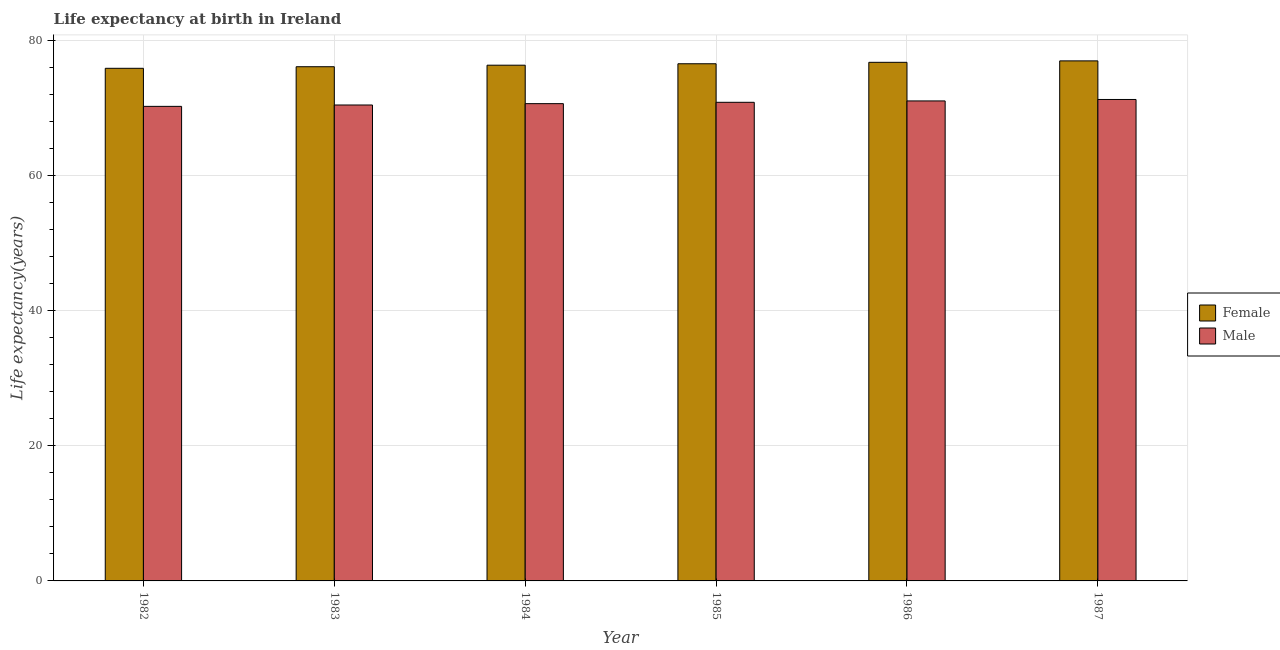Are the number of bars on each tick of the X-axis equal?
Give a very brief answer. Yes. What is the label of the 5th group of bars from the left?
Offer a terse response. 1986. What is the life expectancy(female) in 1986?
Give a very brief answer. 76.78. Across all years, what is the maximum life expectancy(female)?
Ensure brevity in your answer.  76.99. Across all years, what is the minimum life expectancy(female)?
Your answer should be compact. 75.89. In which year was the life expectancy(female) maximum?
Keep it short and to the point. 1987. In which year was the life expectancy(female) minimum?
Provide a succinct answer. 1982. What is the total life expectancy(female) in the graph?
Offer a terse response. 458.69. What is the difference between the life expectancy(male) in 1986 and that in 1987?
Your answer should be very brief. -0.22. What is the difference between the life expectancy(female) in 1985 and the life expectancy(male) in 1983?
Offer a very short reply. 0.44. What is the average life expectancy(female) per year?
Make the answer very short. 76.45. What is the ratio of the life expectancy(male) in 1982 to that in 1986?
Give a very brief answer. 0.99. Is the life expectancy(male) in 1984 less than that in 1986?
Offer a very short reply. Yes. What is the difference between the highest and the second highest life expectancy(female)?
Make the answer very short. 0.21. What is the difference between the highest and the lowest life expectancy(female)?
Ensure brevity in your answer.  1.1. What does the 1st bar from the left in 1987 represents?
Offer a very short reply. Female. How many bars are there?
Offer a very short reply. 12. Are all the bars in the graph horizontal?
Your response must be concise. No. What is the difference between two consecutive major ticks on the Y-axis?
Your answer should be very brief. 20. Are the values on the major ticks of Y-axis written in scientific E-notation?
Make the answer very short. No. How many legend labels are there?
Keep it short and to the point. 2. What is the title of the graph?
Your response must be concise. Life expectancy at birth in Ireland. What is the label or title of the Y-axis?
Your answer should be very brief. Life expectancy(years). What is the Life expectancy(years) in Female in 1982?
Your answer should be very brief. 75.89. What is the Life expectancy(years) in Male in 1982?
Keep it short and to the point. 70.25. What is the Life expectancy(years) of Female in 1983?
Provide a succinct answer. 76.12. What is the Life expectancy(years) of Male in 1983?
Give a very brief answer. 70.46. What is the Life expectancy(years) of Female in 1984?
Offer a very short reply. 76.35. What is the Life expectancy(years) of Male in 1984?
Offer a terse response. 70.66. What is the Life expectancy(years) of Female in 1985?
Your answer should be very brief. 76.56. What is the Life expectancy(years) in Male in 1985?
Keep it short and to the point. 70.86. What is the Life expectancy(years) of Female in 1986?
Your answer should be very brief. 76.78. What is the Life expectancy(years) of Male in 1986?
Provide a short and direct response. 71.06. What is the Life expectancy(years) of Female in 1987?
Offer a very short reply. 76.99. What is the Life expectancy(years) in Male in 1987?
Give a very brief answer. 71.28. Across all years, what is the maximum Life expectancy(years) of Female?
Your response must be concise. 76.99. Across all years, what is the maximum Life expectancy(years) in Male?
Your answer should be compact. 71.28. Across all years, what is the minimum Life expectancy(years) in Female?
Ensure brevity in your answer.  75.89. Across all years, what is the minimum Life expectancy(years) of Male?
Offer a very short reply. 70.25. What is the total Life expectancy(years) in Female in the graph?
Offer a terse response. 458.69. What is the total Life expectancy(years) in Male in the graph?
Your answer should be compact. 424.56. What is the difference between the Life expectancy(years) in Female in 1982 and that in 1983?
Your response must be concise. -0.23. What is the difference between the Life expectancy(years) of Male in 1982 and that in 1983?
Your answer should be compact. -0.2. What is the difference between the Life expectancy(years) in Female in 1982 and that in 1984?
Your answer should be compact. -0.46. What is the difference between the Life expectancy(years) in Male in 1982 and that in 1984?
Offer a terse response. -0.4. What is the difference between the Life expectancy(years) of Female in 1982 and that in 1985?
Provide a short and direct response. -0.67. What is the difference between the Life expectancy(years) of Male in 1982 and that in 1985?
Your answer should be compact. -0.6. What is the difference between the Life expectancy(years) of Female in 1982 and that in 1986?
Provide a short and direct response. -0.89. What is the difference between the Life expectancy(years) of Male in 1982 and that in 1986?
Offer a very short reply. -0.81. What is the difference between the Life expectancy(years) of Female in 1982 and that in 1987?
Keep it short and to the point. -1.1. What is the difference between the Life expectancy(years) in Male in 1982 and that in 1987?
Keep it short and to the point. -1.02. What is the difference between the Life expectancy(years) of Female in 1983 and that in 1984?
Provide a short and direct response. -0.23. What is the difference between the Life expectancy(years) of Female in 1983 and that in 1985?
Offer a terse response. -0.44. What is the difference between the Life expectancy(years) in Male in 1983 and that in 1985?
Ensure brevity in your answer.  -0.4. What is the difference between the Life expectancy(years) in Female in 1983 and that in 1986?
Your response must be concise. -0.65. What is the difference between the Life expectancy(years) in Male in 1983 and that in 1986?
Keep it short and to the point. -0.6. What is the difference between the Life expectancy(years) of Female in 1983 and that in 1987?
Keep it short and to the point. -0.86. What is the difference between the Life expectancy(years) of Male in 1983 and that in 1987?
Give a very brief answer. -0.82. What is the difference between the Life expectancy(years) of Female in 1984 and that in 1985?
Your response must be concise. -0.21. What is the difference between the Life expectancy(years) in Male in 1984 and that in 1985?
Offer a very short reply. -0.2. What is the difference between the Life expectancy(years) of Female in 1984 and that in 1986?
Your response must be concise. -0.43. What is the difference between the Life expectancy(years) in Male in 1984 and that in 1986?
Offer a terse response. -0.4. What is the difference between the Life expectancy(years) of Female in 1984 and that in 1987?
Provide a short and direct response. -0.64. What is the difference between the Life expectancy(years) in Male in 1984 and that in 1987?
Your answer should be very brief. -0.62. What is the difference between the Life expectancy(years) of Female in 1985 and that in 1986?
Provide a succinct answer. -0.21. What is the difference between the Life expectancy(years) of Male in 1985 and that in 1986?
Your answer should be compact. -0.2. What is the difference between the Life expectancy(years) in Female in 1985 and that in 1987?
Ensure brevity in your answer.  -0.43. What is the difference between the Life expectancy(years) in Male in 1985 and that in 1987?
Your answer should be compact. -0.42. What is the difference between the Life expectancy(years) of Female in 1986 and that in 1987?
Your response must be concise. -0.21. What is the difference between the Life expectancy(years) in Male in 1986 and that in 1987?
Keep it short and to the point. -0.21. What is the difference between the Life expectancy(years) of Female in 1982 and the Life expectancy(years) of Male in 1983?
Offer a terse response. 5.43. What is the difference between the Life expectancy(years) in Female in 1982 and the Life expectancy(years) in Male in 1984?
Your answer should be very brief. 5.23. What is the difference between the Life expectancy(years) in Female in 1982 and the Life expectancy(years) in Male in 1985?
Make the answer very short. 5.03. What is the difference between the Life expectancy(years) in Female in 1982 and the Life expectancy(years) in Male in 1986?
Ensure brevity in your answer.  4.83. What is the difference between the Life expectancy(years) in Female in 1982 and the Life expectancy(years) in Male in 1987?
Ensure brevity in your answer.  4.61. What is the difference between the Life expectancy(years) of Female in 1983 and the Life expectancy(years) of Male in 1984?
Make the answer very short. 5.47. What is the difference between the Life expectancy(years) in Female in 1983 and the Life expectancy(years) in Male in 1985?
Give a very brief answer. 5.27. What is the difference between the Life expectancy(years) in Female in 1983 and the Life expectancy(years) in Male in 1986?
Your answer should be compact. 5.06. What is the difference between the Life expectancy(years) of Female in 1983 and the Life expectancy(years) of Male in 1987?
Keep it short and to the point. 4.85. What is the difference between the Life expectancy(years) of Female in 1984 and the Life expectancy(years) of Male in 1985?
Offer a very short reply. 5.49. What is the difference between the Life expectancy(years) in Female in 1984 and the Life expectancy(years) in Male in 1986?
Give a very brief answer. 5.29. What is the difference between the Life expectancy(years) of Female in 1984 and the Life expectancy(years) of Male in 1987?
Make the answer very short. 5.07. What is the difference between the Life expectancy(years) in Female in 1985 and the Life expectancy(years) in Male in 1986?
Give a very brief answer. 5.5. What is the difference between the Life expectancy(years) of Female in 1985 and the Life expectancy(years) of Male in 1987?
Provide a short and direct response. 5.29. What is the difference between the Life expectancy(years) in Female in 1986 and the Life expectancy(years) in Male in 1987?
Offer a very short reply. 5.5. What is the average Life expectancy(years) of Female per year?
Offer a terse response. 76.45. What is the average Life expectancy(years) in Male per year?
Give a very brief answer. 70.76. In the year 1982, what is the difference between the Life expectancy(years) of Female and Life expectancy(years) of Male?
Provide a succinct answer. 5.63. In the year 1983, what is the difference between the Life expectancy(years) of Female and Life expectancy(years) of Male?
Your answer should be very brief. 5.67. In the year 1984, what is the difference between the Life expectancy(years) in Female and Life expectancy(years) in Male?
Your response must be concise. 5.69. In the year 1985, what is the difference between the Life expectancy(years) in Female and Life expectancy(years) in Male?
Ensure brevity in your answer.  5.71. In the year 1986, what is the difference between the Life expectancy(years) in Female and Life expectancy(years) in Male?
Your answer should be very brief. 5.71. In the year 1987, what is the difference between the Life expectancy(years) of Female and Life expectancy(years) of Male?
Give a very brief answer. 5.71. What is the ratio of the Life expectancy(years) in Male in 1982 to that in 1983?
Give a very brief answer. 1. What is the ratio of the Life expectancy(years) in Female in 1982 to that in 1984?
Offer a very short reply. 0.99. What is the ratio of the Life expectancy(years) in Male in 1982 to that in 1984?
Your answer should be compact. 0.99. What is the ratio of the Life expectancy(years) of Female in 1982 to that in 1985?
Ensure brevity in your answer.  0.99. What is the ratio of the Life expectancy(years) of Male in 1982 to that in 1985?
Keep it short and to the point. 0.99. What is the ratio of the Life expectancy(years) of Male in 1982 to that in 1986?
Your answer should be very brief. 0.99. What is the ratio of the Life expectancy(years) in Female in 1982 to that in 1987?
Keep it short and to the point. 0.99. What is the ratio of the Life expectancy(years) in Male in 1982 to that in 1987?
Your response must be concise. 0.99. What is the ratio of the Life expectancy(years) in Female in 1983 to that in 1984?
Your answer should be very brief. 1. What is the ratio of the Life expectancy(years) of Female in 1984 to that in 1985?
Your answer should be very brief. 1. What is the ratio of the Life expectancy(years) of Female in 1984 to that in 1986?
Your answer should be very brief. 0.99. What is the ratio of the Life expectancy(years) of Male in 1984 to that in 1986?
Your answer should be very brief. 0.99. What is the ratio of the Life expectancy(years) in Male in 1984 to that in 1987?
Your response must be concise. 0.99. What is the ratio of the Life expectancy(years) of Male in 1985 to that in 1986?
Make the answer very short. 1. What is the ratio of the Life expectancy(years) in Male in 1985 to that in 1987?
Give a very brief answer. 0.99. What is the ratio of the Life expectancy(years) in Male in 1986 to that in 1987?
Your response must be concise. 1. What is the difference between the highest and the second highest Life expectancy(years) in Female?
Ensure brevity in your answer.  0.21. What is the difference between the highest and the second highest Life expectancy(years) of Male?
Offer a terse response. 0.21. What is the difference between the highest and the lowest Life expectancy(years) of Male?
Ensure brevity in your answer.  1.02. 